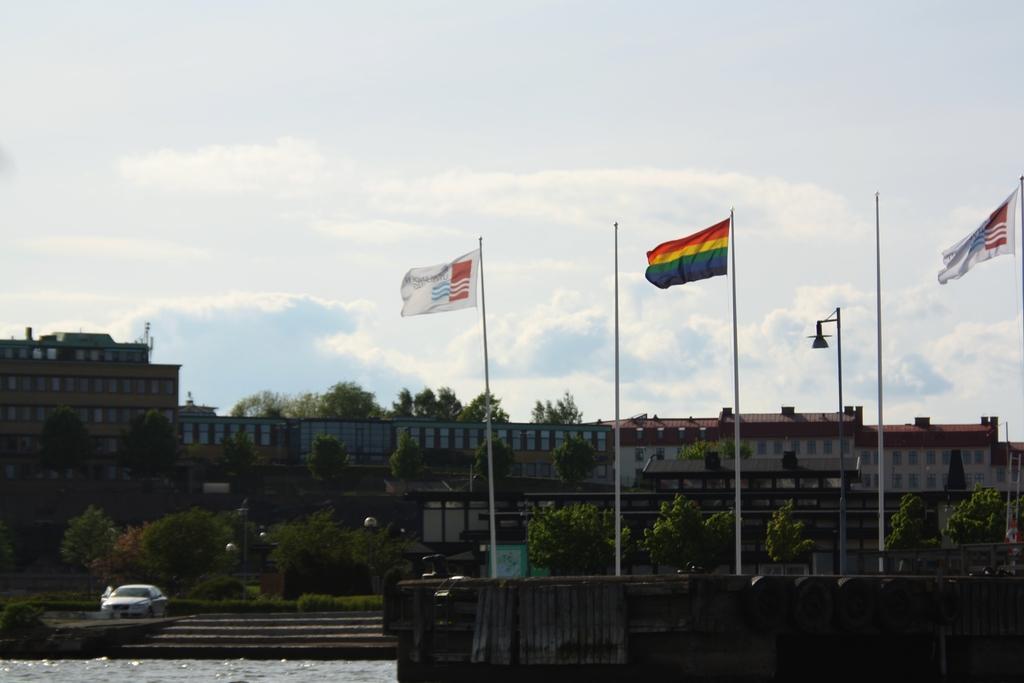Describe this image in one or two sentences. In this image we can see poles, flags, water, plants, trees, and buildings. There is a car. In the background we can see sky with clouds. 